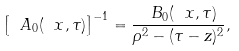<formula> <loc_0><loc_0><loc_500><loc_500>\left [ \ A _ { 0 } ( \ x , \tau ) \right ] ^ { - 1 } = \frac { \ B _ { 0 } ( \ x , \tau ) } { \rho ^ { 2 } - ( \tau - z ) ^ { 2 } } ,</formula> 